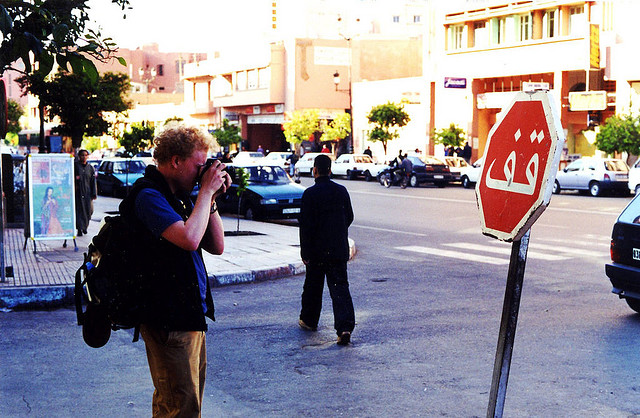<image>What does the red sign say? It is unknown what the red sign says. However, it could possibly say 'stop'. What does the red sign say? I don't know what the red sign says. It can be seen 'stop'. 